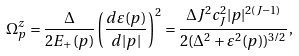Convert formula to latex. <formula><loc_0><loc_0><loc_500><loc_500>\Omega _ { p } ^ { z } = \frac { \Delta } { 2 E _ { + } ( p ) } \left ( \frac { { d } \varepsilon ( p ) } { { d } | p | } \right ) ^ { 2 } = \frac { \Delta J ^ { 2 } c _ { J } ^ { 2 } | p | ^ { 2 ( J - 1 ) } } { 2 ( \Delta ^ { 2 } + \varepsilon ^ { 2 } ( p ) ) ^ { 3 / 2 } } ,</formula> 